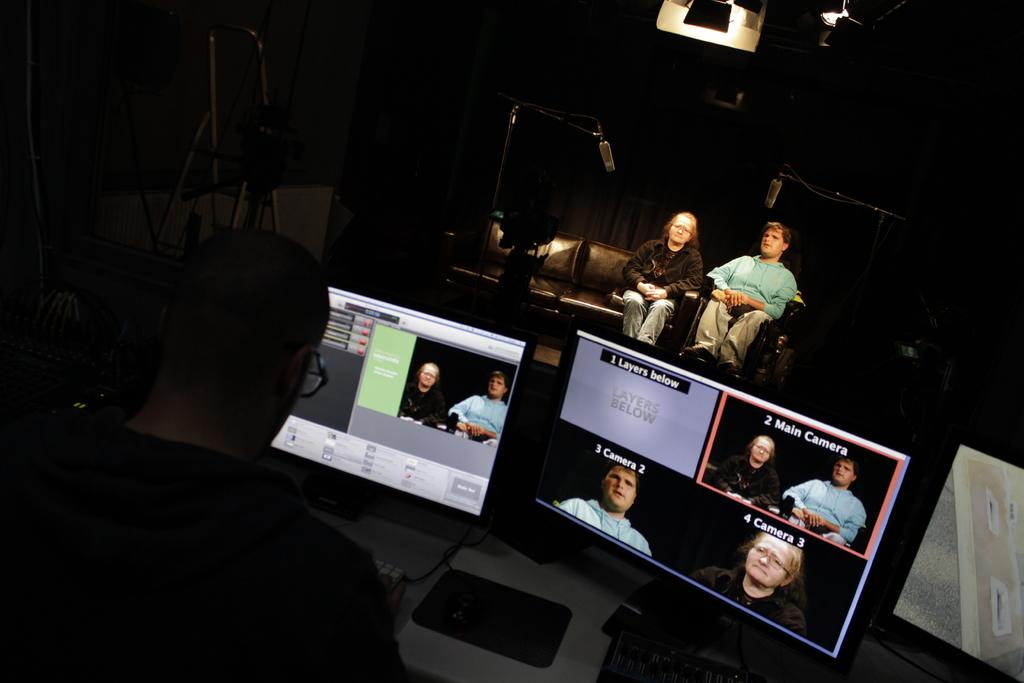<image>
Summarize the visual content of the image. A computer screen shows several different camera views, including main camera, camera 2, and camera 3. 